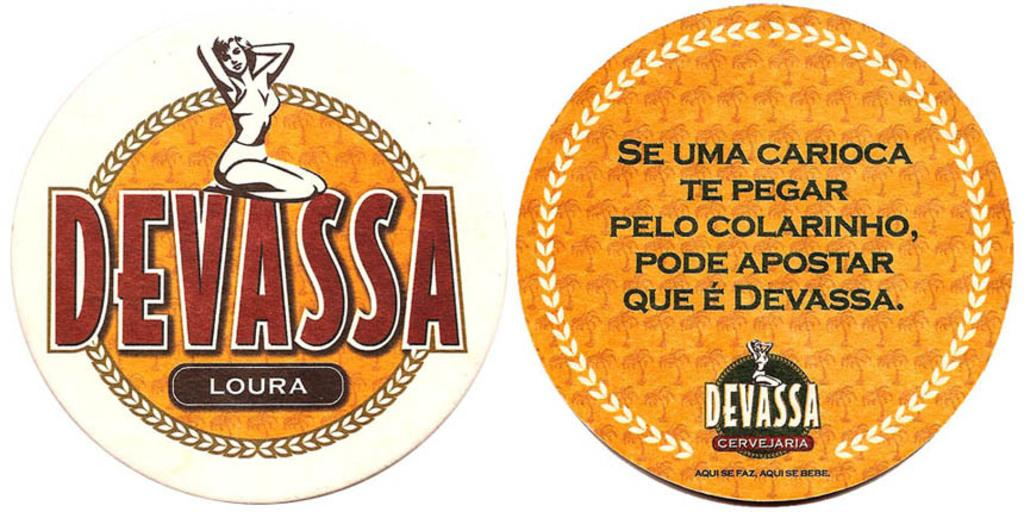What can be found in the image that contains written information? There is some text in the image. What type of symbol is present in the image? There is a logo in the image. How does the tongue contribute to the image? There is no tongue present in the image. What health benefits are mentioned in the image? The image does not mention any health benefits; it contains text and a logo. 